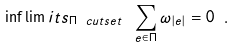Convert formula to latex. <formula><loc_0><loc_0><loc_500><loc_500>\inf \lim i t s _ { \Pi \ c u t s e t } \ \sum _ { e \in \Pi } \omega _ { | e | } = 0 \ .</formula> 